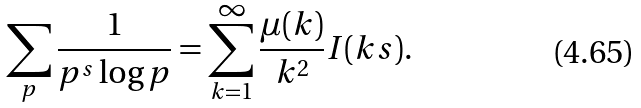<formula> <loc_0><loc_0><loc_500><loc_500>\sum _ { p } \frac { 1 } { p ^ { s } \log p } = \sum _ { k = 1 } ^ { \infty } \frac { \mu ( k ) } { k ^ { 2 } } I ( k s ) .</formula> 